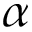Convert formula to latex. <formula><loc_0><loc_0><loc_500><loc_500>\alpha</formula> 